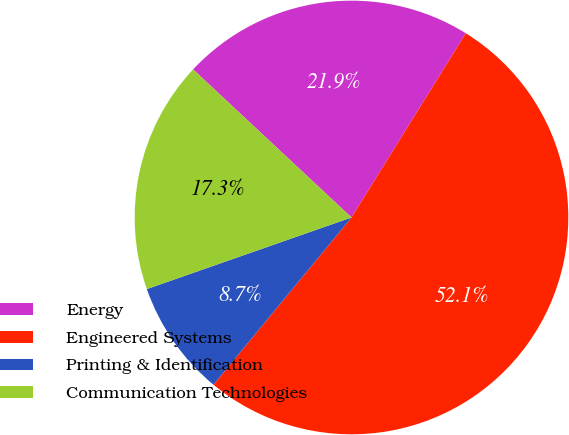Convert chart to OTSL. <chart><loc_0><loc_0><loc_500><loc_500><pie_chart><fcel>Energy<fcel>Engineered Systems<fcel>Printing & Identification<fcel>Communication Technologies<nl><fcel>21.88%<fcel>52.14%<fcel>8.66%<fcel>17.32%<nl></chart> 